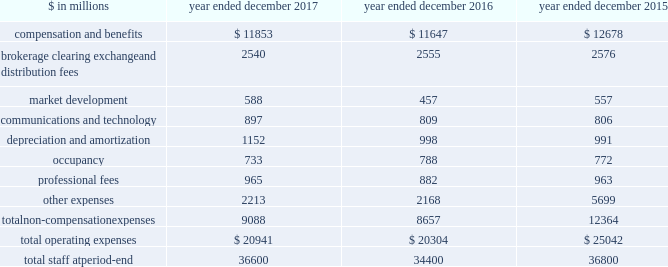The goldman sachs group , inc .
And subsidiaries management 2019s discussion and analysis other principal transactions revenues in the consolidated statements of earnings were $ 3.20 billion for 2016 , 36% ( 36 % ) lower than 2015 , primarily due to significantly lower revenues from investments in equities , primarily reflecting a significant decrease in net gains from private equities , driven by company-specific events and corporate performance .
In addition , revenues in debt securities and loans were significantly lower compared with 2015 , reflecting significantly lower revenues related to relationship lending activities , due to the impact of changes in credit spreads on economic hedges .
Losses related to these hedges were $ 596 million in 2016 , compared with gains of $ 329 million in 2015 .
This decrease was partially offset by higher net gains from investments in debt instruments .
See note 9 to the consolidated financial statements for further information about economic hedges related to our relationship lending activities .
Net interest income .
Net interest income in the consolidated statements of earnings was $ 2.59 billion for 2016 , 16% ( 16 % ) lower than 2015 , reflecting an increase in interest expense primarily due to the impact of higher interest rates on other interest-bearing liabilities , interest- bearing deposits and collateralized financings , and increases in total average long-term borrowings and total average interest-bearing deposits .
The increase in interest expense was partially offset by higher interest income related to collateralized agreements , reflecting the impact of higher interest rates , and loans receivable , reflecting an increase in total average balances and the impact of higher interest rates .
See 201cstatistical disclosures 2014 distribution of assets , liabilities and shareholders 2019 equity 201d for further information about our sources of net interest income .
Operating expenses our operating expenses are primarily influenced by compensation , headcount and levels of business activity .
Compensation and benefits includes salaries , discretionary compensation , amortization of equity awards and other items such as benefits .
Discretionary compensation is significantly impacted by , among other factors , the level of net revenues , overall financial performance , prevailing labor markets , business mix , the structure of our share- based compensation programs and the external environment .
In addition , see 201cuse of estimates 201d for further information about expenses that may arise from litigation and regulatory proceedings .
In the context of the challenging environment , we completed an initiative during 2016 that identified areas where we can operate more efficiently , resulting in a reduction of approximately $ 900 million in annual run rate compensation .
For 2016 , net savings from this initiative , after severance and other related costs , were approximately $ 500 million .
The table below presents our operating expenses and total staff ( including employees , consultants and temporary staff ) . .
In the table above , other expenses for 2015 included $ 3.37 billion recorded for the settlement agreement with the rmbs working group .
See note 27 to the consolidated financial statements in part ii , item 8 of our annual report on form 10-k for the year ended december 31 , 2015 for further information .
2017 versus 2016 .
Operating expenses in the consolidated statements of earnings were $ 20.94 billion for 2017 , 3% ( 3 % ) higher than 2016 .
Compensation and benefits expenses in the consolidated statements of earnings were $ 11.85 billion for 2017 , 2% ( 2 % ) higher than 2016 .
The ratio of compensation and benefits to net revenues for 2017 was 37.0% ( 37.0 % ) compared with 38.1% ( 38.1 % ) for 2016 .
Non-compensation expenses in the consolidated statements of earnings were $ 9.09 billion for 2017 , 5% ( 5 % ) higher than 2016 , primarily driven by our investments to fund growth .
The increase compared with 2016 reflected higher expenses related to consolidated investments and our digital lending and deposit platform , marcus : by goldman sachs ( marcus ) .
These increases were primarily included in depreciation and amortization expenses , market development expenses and other expenses .
In addition , technology expenses increased , reflecting higher expenses related to cloud-based services and software depreciation , and professional fees increased , primarily related to consulting costs .
These increases were partially offset by lower net provisions for litigation and regulatory proceedings , and lower occupancy expenses ( primarily related to exit costs in 2016 ) .
Net provisions for litigation and regulatory proceedings for 2017 were $ 188 million compared with $ 396 million for 2016 .
2017 included a $ 127 million charitable contribution to goldman sachs gives , our donor-advised fund .
Compensation was reduced to fund this charitable contribution to goldman sachs gives .
We ask our participating managing directors to make recommendations regarding potential charitable recipients for this contribution .
54 goldman sachs 2017 form 10-k .
What portion of total operating expenses is related to compensation and benefits in 2016? 
Computations: (11647 / 20304)
Answer: 0.57363. 